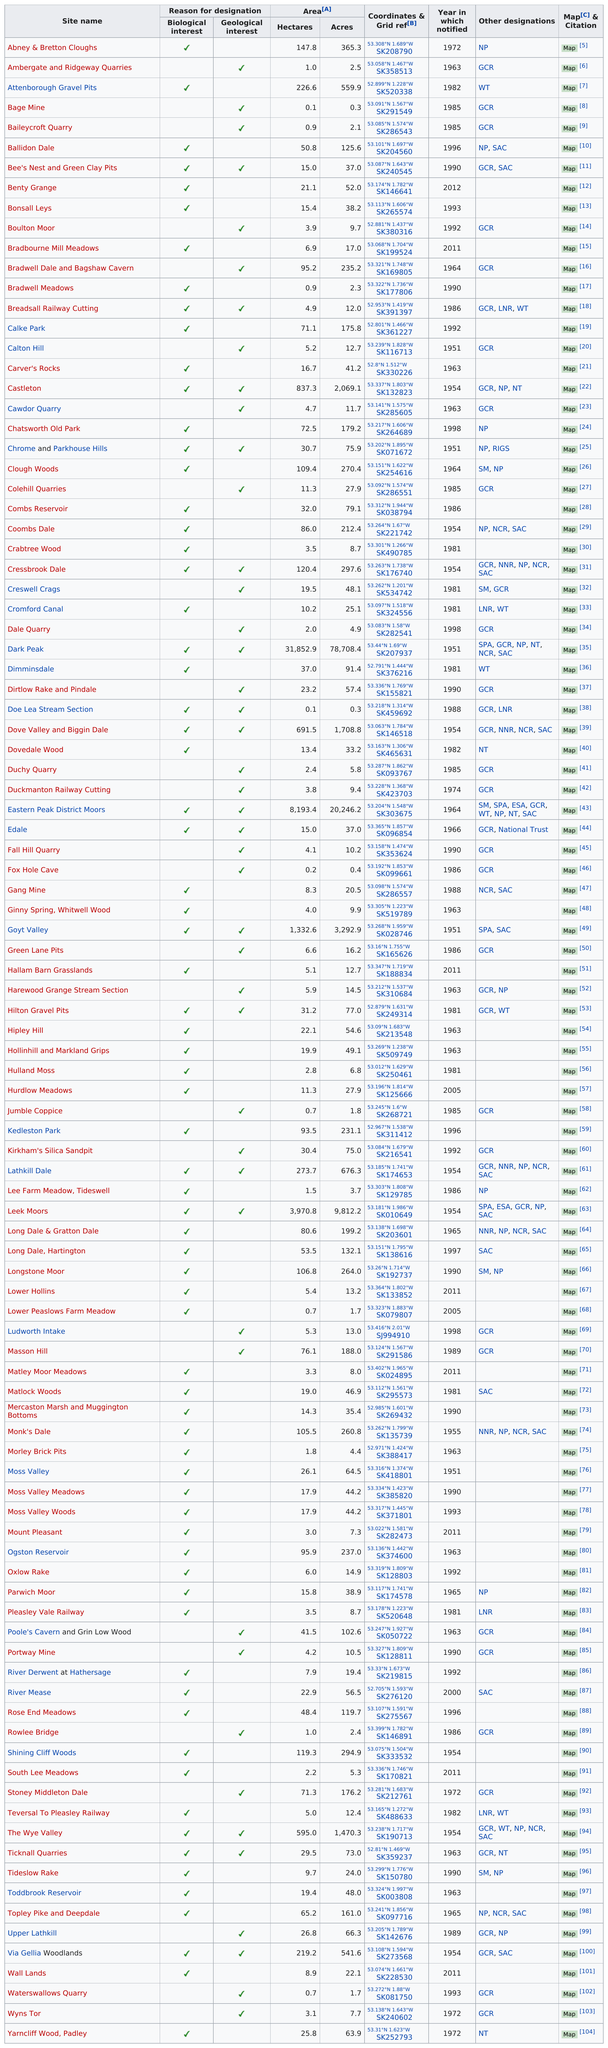Point out several critical features in this image. There are 17 sites that have both biological and geological interest. Carver's Rocks is larger than Cawdo Quarry in terms of acres. The number of acres in Castledon is 2,069.1. The National Park Service has designated 17 sites that have both a biological and geological interest. Hurdlow Meadows has a greater area than Wall Lands. 